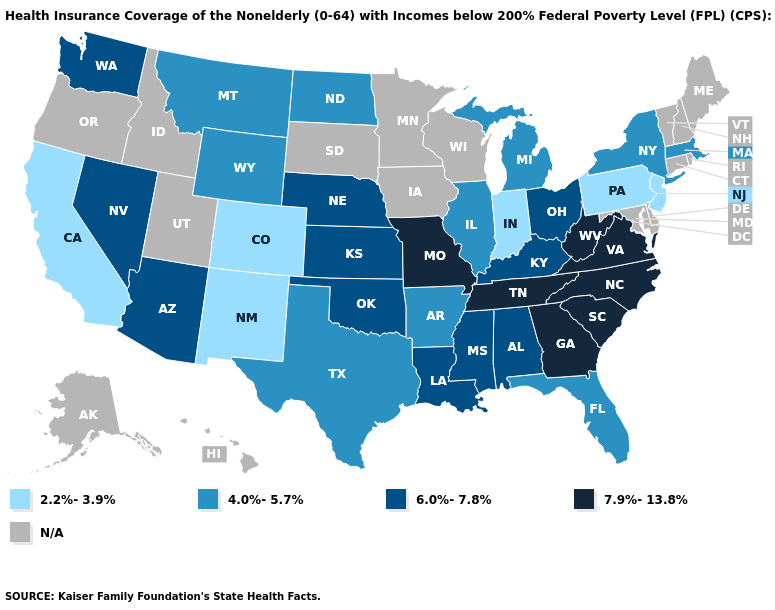Which states have the highest value in the USA?
Keep it brief. Georgia, Missouri, North Carolina, South Carolina, Tennessee, Virginia, West Virginia. Which states have the lowest value in the USA?
Keep it brief. California, Colorado, Indiana, New Jersey, New Mexico, Pennsylvania. What is the highest value in the USA?
Give a very brief answer. 7.9%-13.8%. What is the highest value in the USA?
Write a very short answer. 7.9%-13.8%. What is the value of Illinois?
Concise answer only. 4.0%-5.7%. What is the value of Delaware?
Write a very short answer. N/A. Does Ohio have the lowest value in the MidWest?
Keep it brief. No. Does New Jersey have the highest value in the Northeast?
Short answer required. No. Name the states that have a value in the range 4.0%-5.7%?
Be succinct. Arkansas, Florida, Illinois, Massachusetts, Michigan, Montana, New York, North Dakota, Texas, Wyoming. What is the value of Kansas?
Short answer required. 6.0%-7.8%. Name the states that have a value in the range 7.9%-13.8%?
Write a very short answer. Georgia, Missouri, North Carolina, South Carolina, Tennessee, Virginia, West Virginia. Name the states that have a value in the range N/A?
Concise answer only. Alaska, Connecticut, Delaware, Hawaii, Idaho, Iowa, Maine, Maryland, Minnesota, New Hampshire, Oregon, Rhode Island, South Dakota, Utah, Vermont, Wisconsin. Does Florida have the lowest value in the USA?
Short answer required. No. Does the first symbol in the legend represent the smallest category?
Give a very brief answer. Yes. 